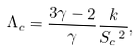<formula> <loc_0><loc_0><loc_500><loc_500>\Lambda _ { c } = \frac { 3 \gamma - 2 } { \gamma } \frac { k } { S _ { c } \, ^ { 2 } } ,</formula> 